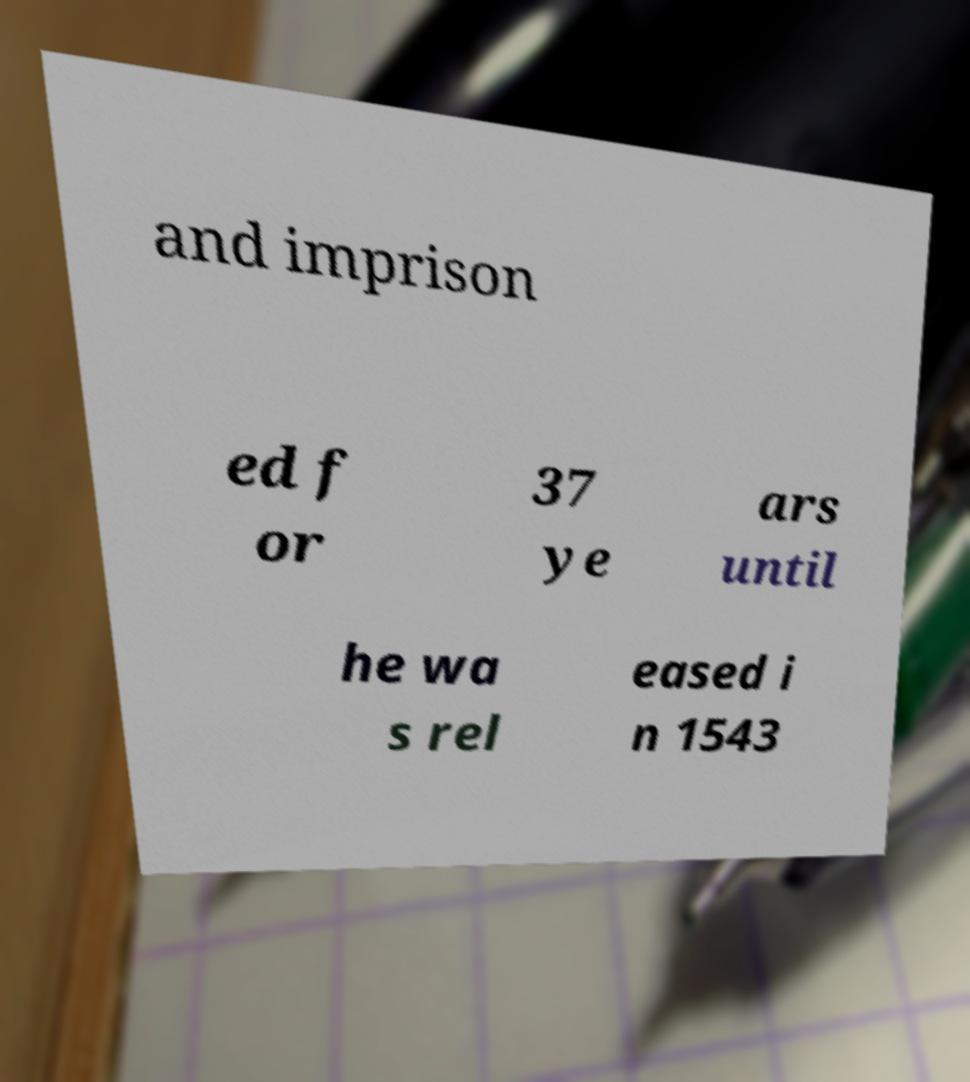Can you read and provide the text displayed in the image?This photo seems to have some interesting text. Can you extract and type it out for me? and imprison ed f or 37 ye ars until he wa s rel eased i n 1543 